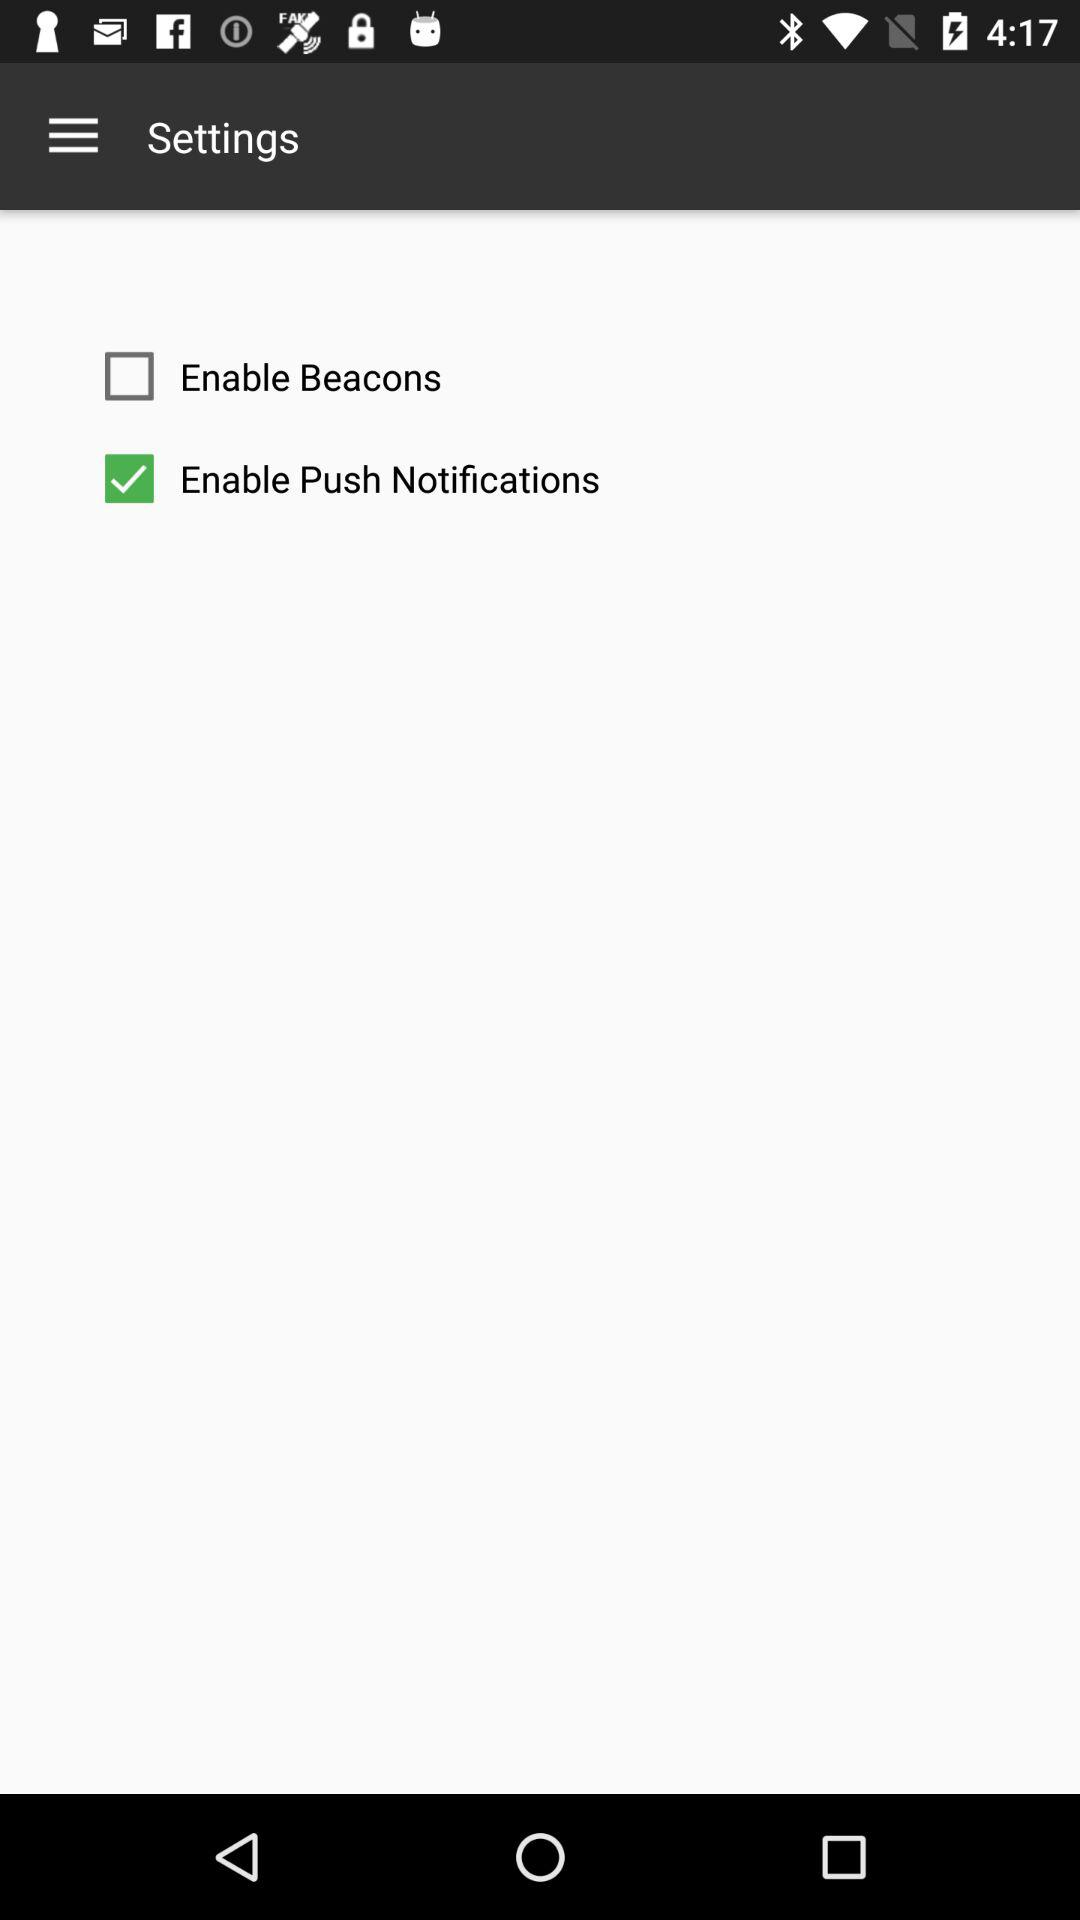Which is the unchecked notification? The unchecked notification is "Enable Beacons". 